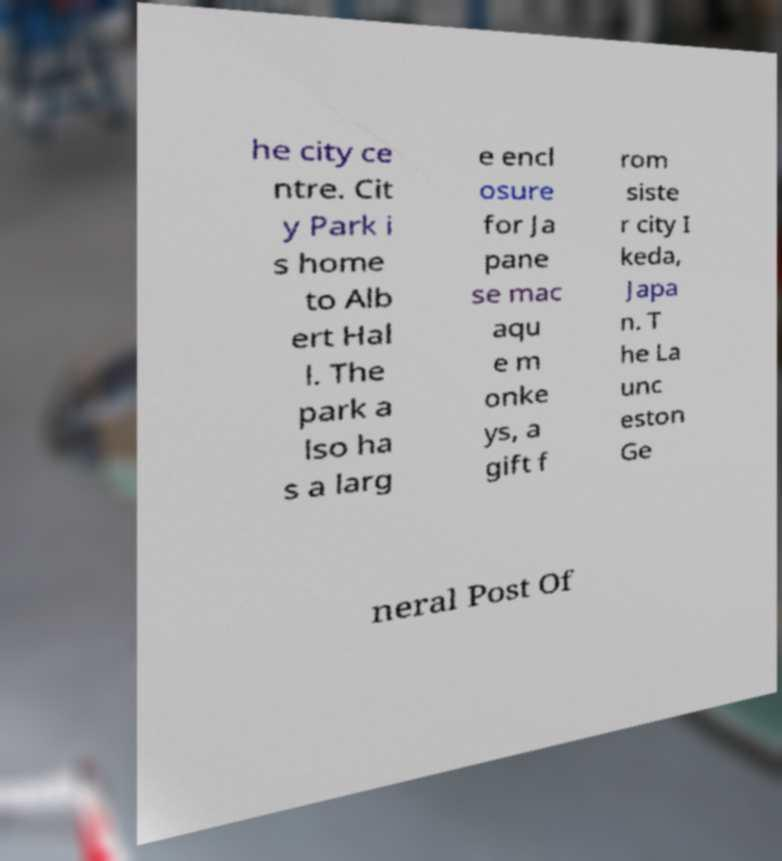Could you assist in decoding the text presented in this image and type it out clearly? he city ce ntre. Cit y Park i s home to Alb ert Hal l. The park a lso ha s a larg e encl osure for Ja pane se mac aqu e m onke ys, a gift f rom siste r city I keda, Japa n. T he La unc eston Ge neral Post Of 